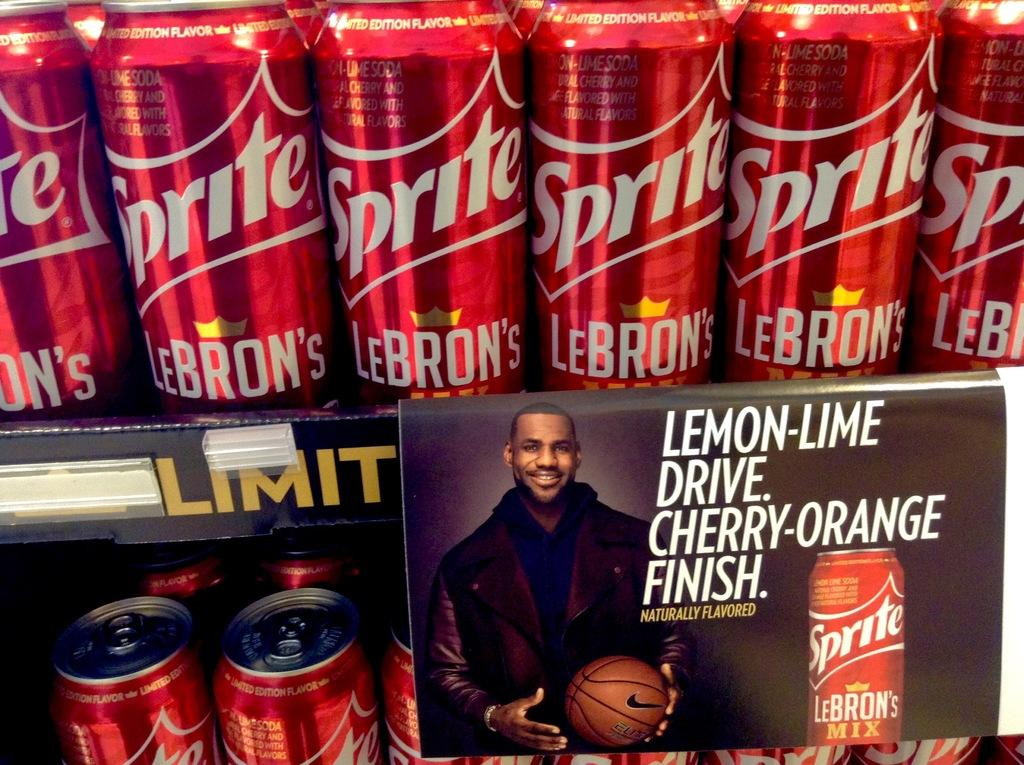Provide a one-sentence caption for the provided image. Many cans of LeBron's Sprite line the shelves. 